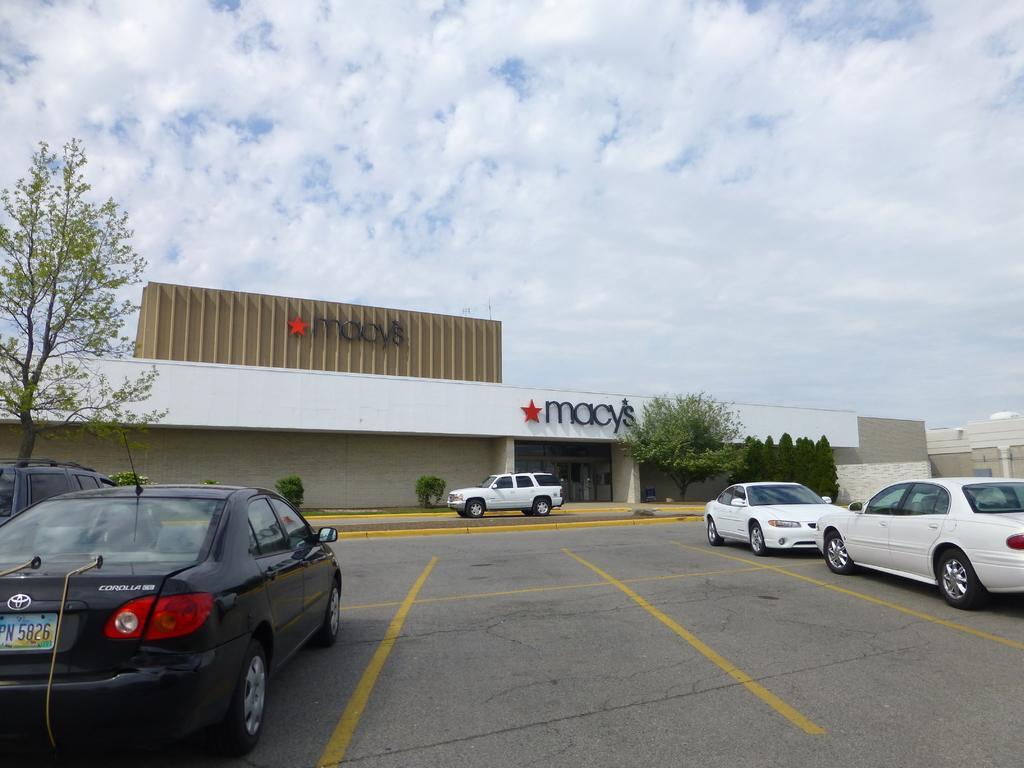How would you summarize this image in a sentence or two? In the picture we can see a parking surface on it, we can see some cars are parked and in the background, we can see some plants and building with a name on it star Macy's and besides the building we can see some trees and plants and in the background we can see a sky with clouds. 